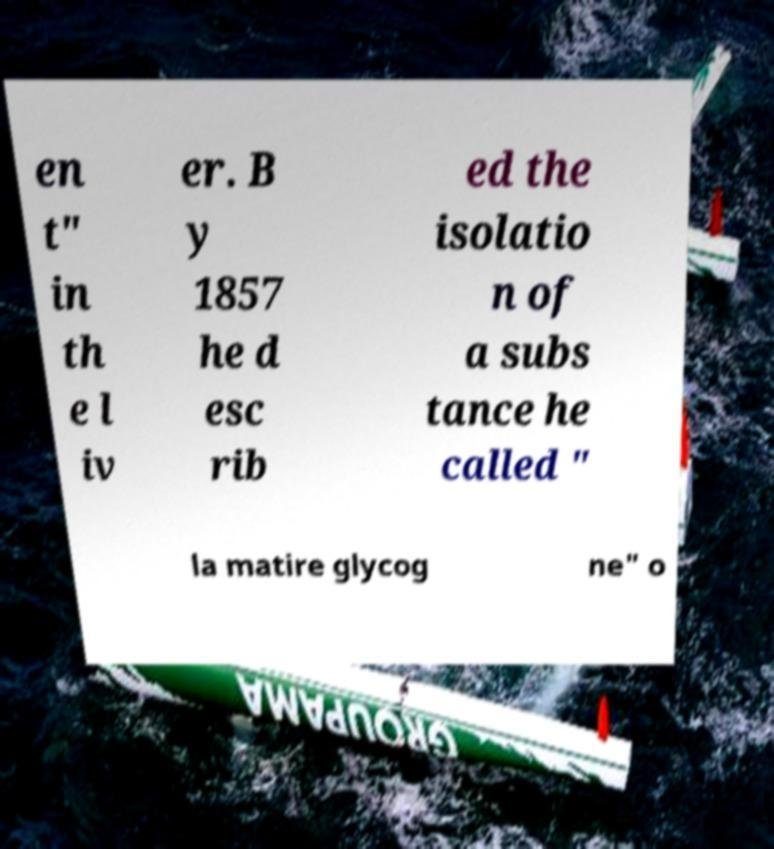I need the written content from this picture converted into text. Can you do that? en t" in th e l iv er. B y 1857 he d esc rib ed the isolatio n of a subs tance he called " la matire glycog ne" o 